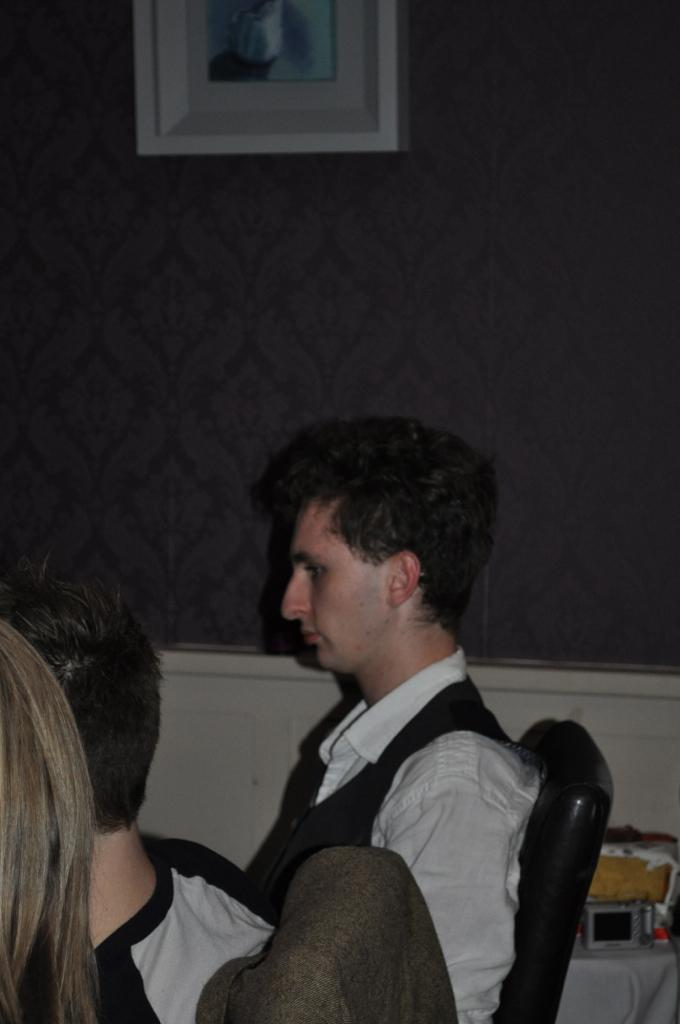What are the people in the image doing? The people in the image are sitting on chairs. What can be seen on the wall in the image? There is a photo frame on the wall in the image. What is located in the bottom right corner of the image? There are items on a table in the bottom right corner of the image. Can you see a hill in the background of the image? There is no hill visible in the image. 